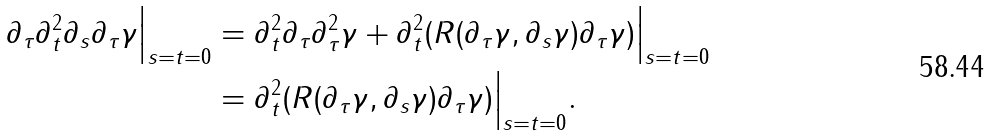<formula> <loc_0><loc_0><loc_500><loc_500>\partial _ { \tau } \partial _ { t } ^ { 2 } \partial _ { s } \partial _ { \tau } \gamma \Big | _ { s = t = 0 } & = \partial _ { t } ^ { 2 } \partial _ { \tau } \partial _ { \tau } ^ { 2 } \gamma + \partial _ { t } ^ { 2 } ( R ( \partial _ { \tau } \gamma , \partial _ { s } \gamma ) \partial _ { \tau } \gamma ) \Big | _ { s = t = 0 } \\ & = \partial _ { t } ^ { 2 } ( R ( \partial _ { \tau } \gamma , \partial _ { s } \gamma ) \partial _ { \tau } \gamma ) \Big | _ { s = t = 0 } .</formula> 